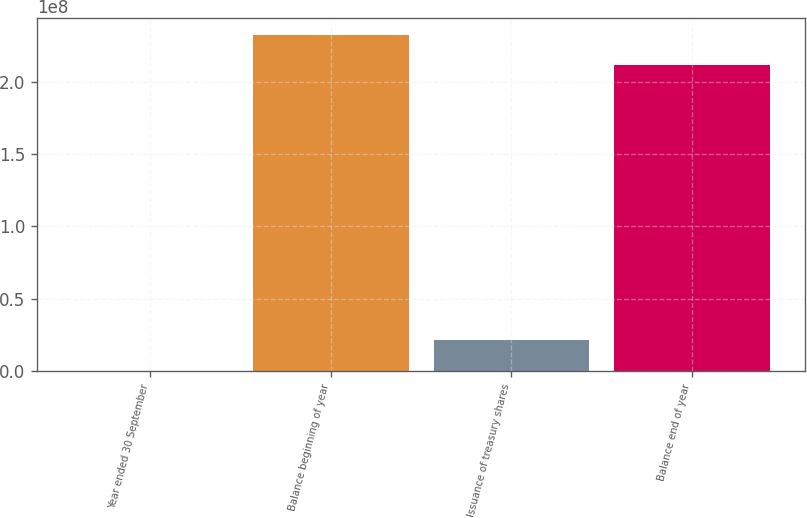<chart> <loc_0><loc_0><loc_500><loc_500><bar_chart><fcel>Year ended 30 September<fcel>Balance beginning of year<fcel>Issuance of treasury shares<fcel>Balance end of year<nl><fcel>2013<fcel>2.32427e+08<fcel>2.12494e+07<fcel>2.11179e+08<nl></chart> 